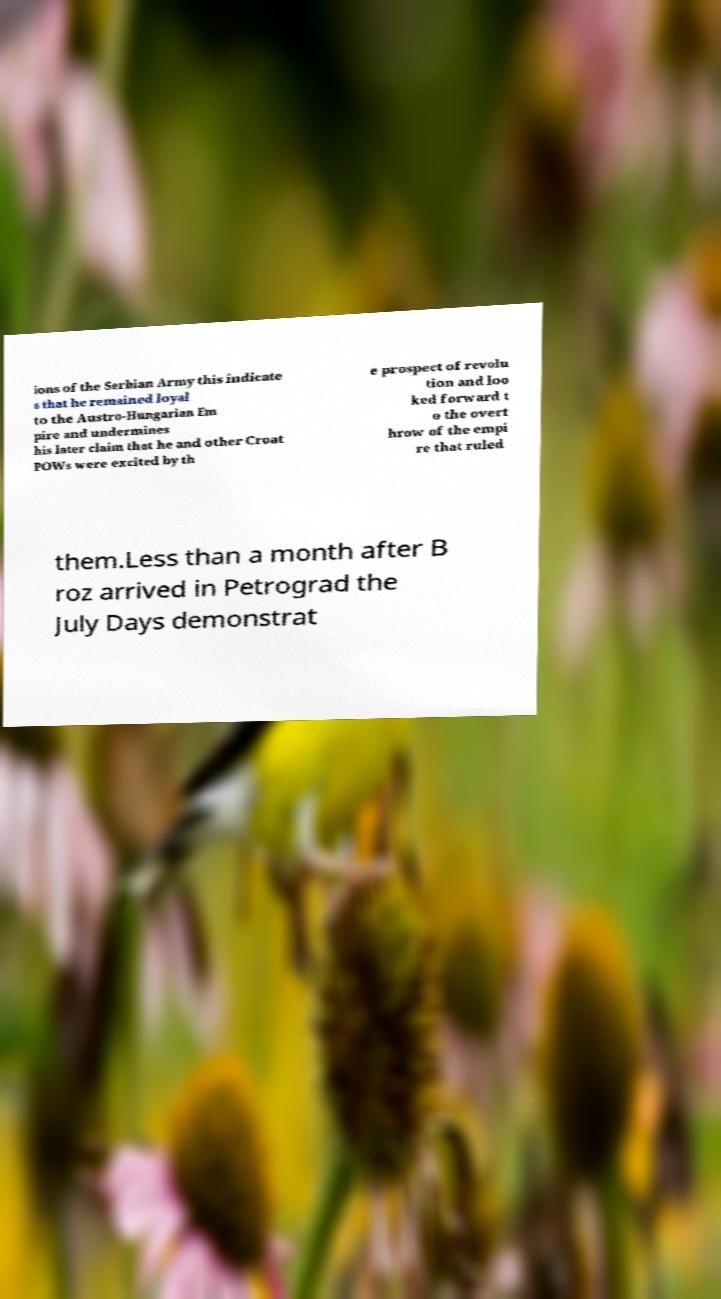Could you assist in decoding the text presented in this image and type it out clearly? ions of the Serbian Army this indicate s that he remained loyal to the Austro-Hungarian Em pire and undermines his later claim that he and other Croat POWs were excited by th e prospect of revolu tion and loo ked forward t o the overt hrow of the empi re that ruled them.Less than a month after B roz arrived in Petrograd the July Days demonstrat 